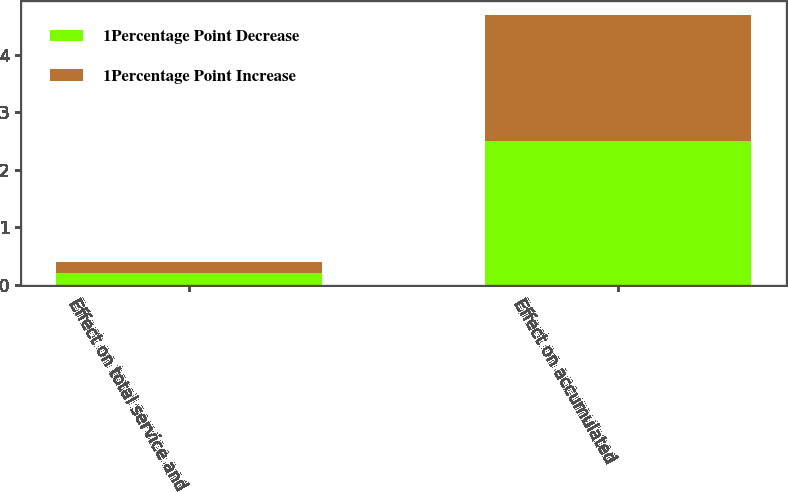<chart> <loc_0><loc_0><loc_500><loc_500><stacked_bar_chart><ecel><fcel>Effect on total service and<fcel>Effect on accumulated<nl><fcel>1Percentage Point Decrease<fcel>0.2<fcel>2.5<nl><fcel>1Percentage Point Increase<fcel>0.2<fcel>2.2<nl></chart> 